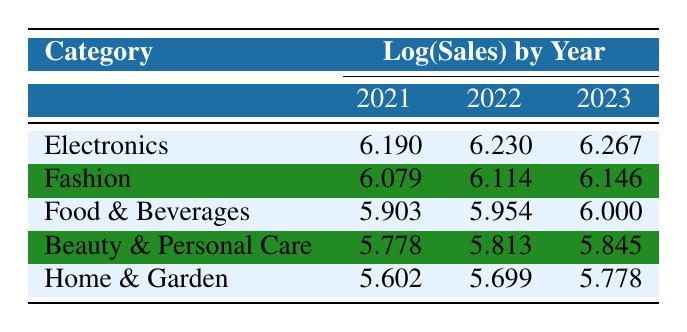What is the logarithmic sales value for Fashion in 2023? Looking at the table, we find the row for Fashion and the corresponding column for the year 2023, which shows the value 6.146.
Answer: 6.146 Which product category had the lowest logarithmic sales value in 2021? The table lists the logarithmic sales values for each category in 2021. Comparing them, Home & Garden at 5.602 is the lowest.
Answer: Home & Garden What is the difference in logarithmic sales value for Food & Beverages from 2021 to 2023? The value for Food & Beverages in 2021 is 5.903 and in 2023 is 6.000. The difference is 6.000 - 5.903 = 0.097.
Answer: 0.097 Did Beauty & Personal Care have an increase in logarithmic sales value from 2021 to 2022? Comparing the values for Beauty & Personal Care, it went from 5.778 in 2021 to 5.813 in 2022, indicating an increase.
Answer: Yes What is the average logarithmic sales value for Electronics and Fashion in 2022? For Electronics in 2022, the value is 6.230, and for Fashion, it is 6.114. The average is (6.230 + 6.114) / 2 = 6.172.
Answer: 6.172 Which category had the highest growth in logarithmic sales value from 2021 to 2023? Examining the changes from 2021 to 2023, the increases are as follows: Electronics +0.077, Fashion +0.067, Food & Beverages +0.097, Beauty & Personal Care +0.067, Home & Garden +0.176. Home & Garden shows the highest growth.
Answer: Home & Garden Is the logarithmic sales value for Home & Garden in 2023 greater than that for Food & Beverages in 2022? The value for Home & Garden in 2023 is 5.778, while for Food & Beverages in 2022, it is 5.954. Since 5.778 < 5.954, it is not greater.
Answer: No 